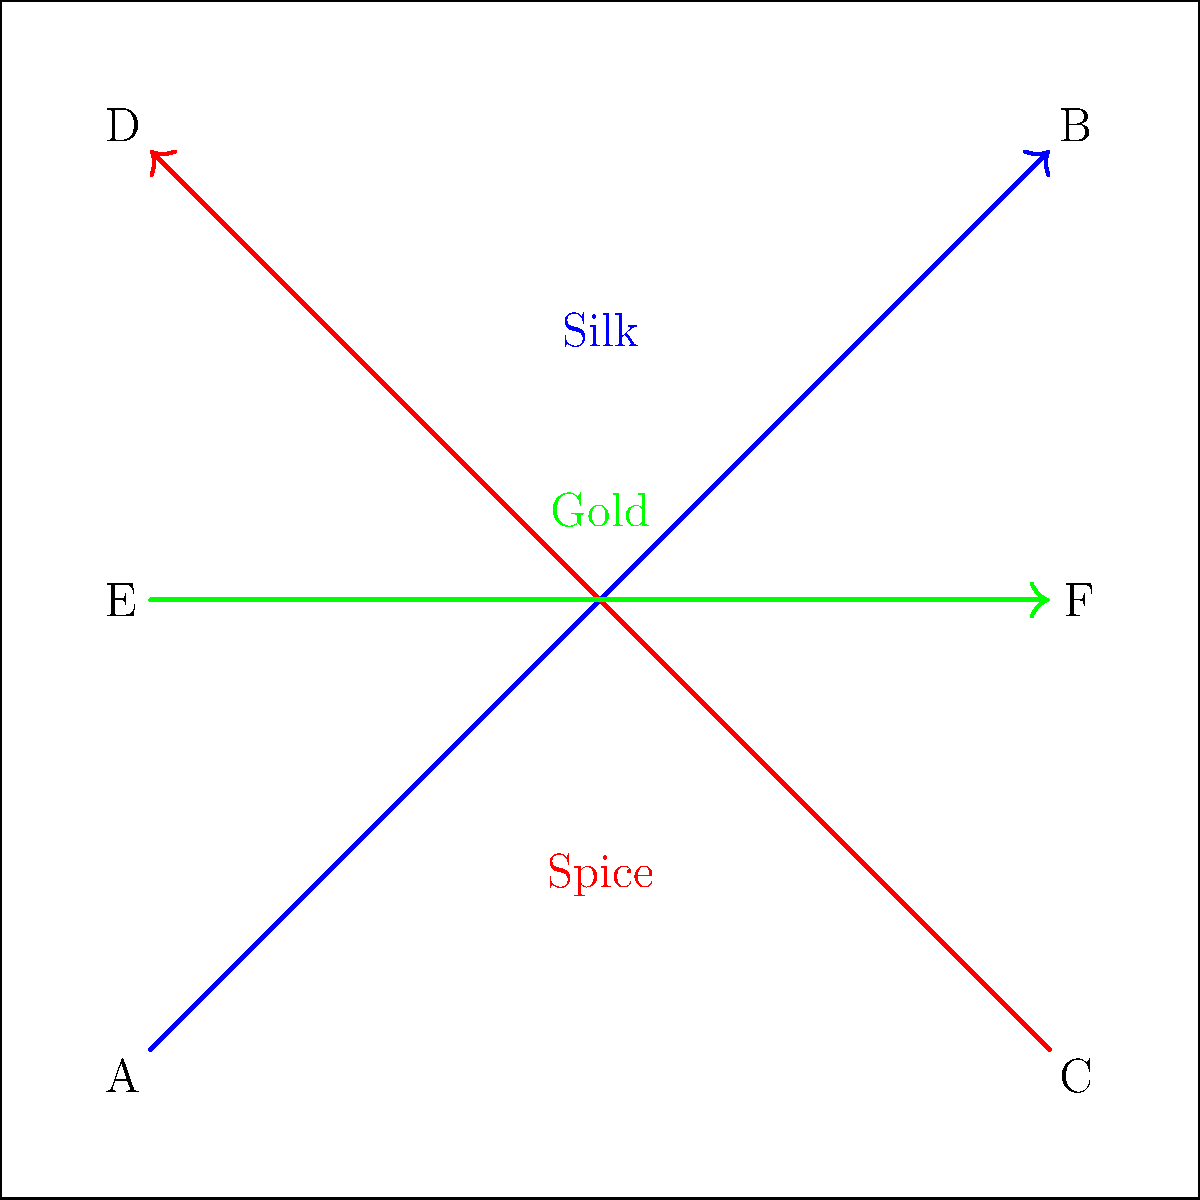Based on the map of trade routes shown, which city is likely to experience the most significant economic growth due to its strategic position on all three major trade routes (Silk, Spice, and Gold)? To determine which city is likely to experience the most significant economic growth, we need to analyze the trade routes and their intersections:

1. Identify the trade routes:
   - Blue route (Silk): connects cities A and B
   - Red route (Spice): connects cities C and D
   - Green route (Gold): connects cities E and F

2. Examine the position of each city:
   - City A: Located at one end of the Silk route
   - City B: Located at one end of the Silk route
   - City C: Located at one end of the Spice route
   - City D: Located at one end of the Spice route
   - City E: Located at one end of the Gold route and on the Silk and Spice routes
   - City F: Located at one end of the Gold route and on the Silk and Spice routes

3. Analyze the strategic importance:
   - Cities A, B, C, and D are each located on only one trade route
   - Cities E and F are located on all three trade routes

4. Consider the economic impact:
   - Cities located on multiple trade routes have more opportunities for trade, cultural exchange, and economic growth
   - Being at the intersection of all three routes provides the greatest advantage in terms of access to diverse goods and markets

5. Conclusion:
   Both cities E and F are positioned on all three major trade routes, making them the most likely candidates for significant economic growth. However, since the question asks for a single city, we must choose one. Given that they have equivalent positions, either E or F would be a correct answer.

For the purposes of this question, we'll select City E as our answer, but note that City F would be equally valid.
Answer: City E 